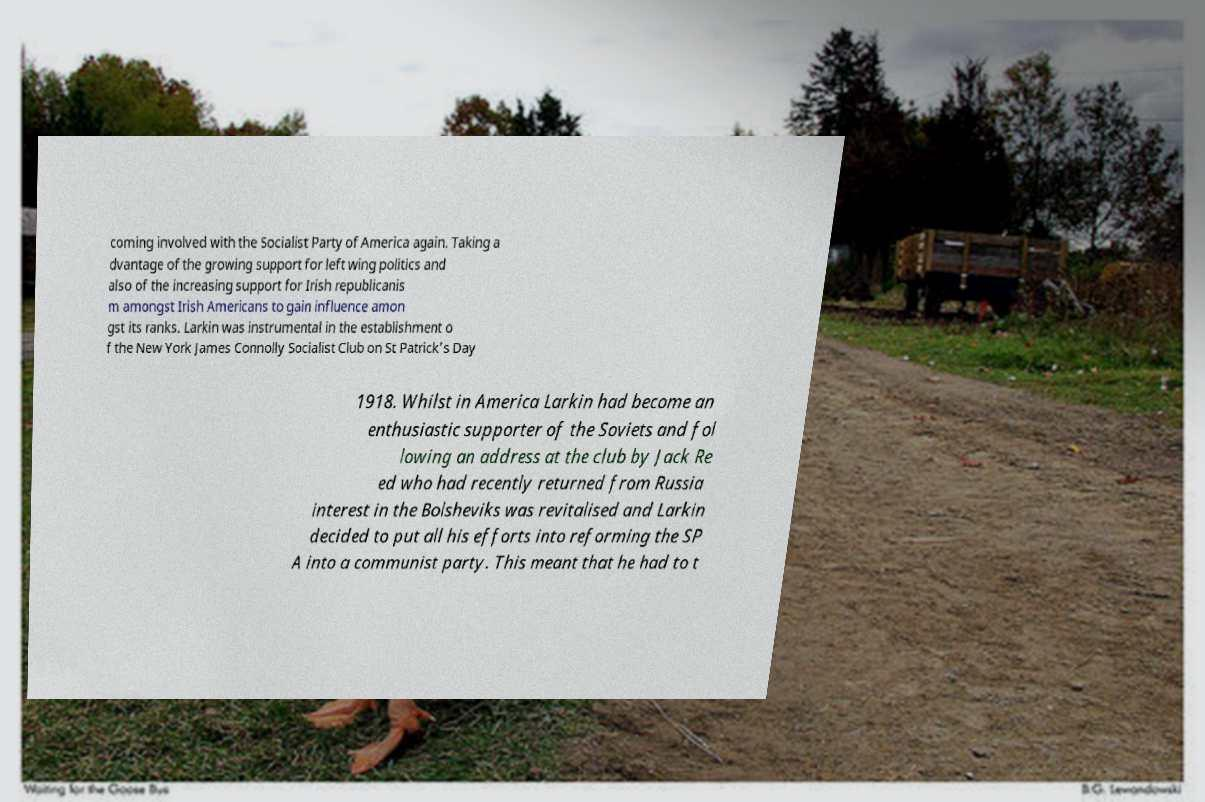Please read and relay the text visible in this image. What does it say? coming involved with the Socialist Party of America again. Taking a dvantage of the growing support for left wing politics and also of the increasing support for Irish republicanis m amongst Irish Americans to gain influence amon gst its ranks. Larkin was instrumental in the establishment o f the New York James Connolly Socialist Club on St Patrick's Day 1918. Whilst in America Larkin had become an enthusiastic supporter of the Soviets and fol lowing an address at the club by Jack Re ed who had recently returned from Russia interest in the Bolsheviks was revitalised and Larkin decided to put all his efforts into reforming the SP A into a communist party. This meant that he had to t 